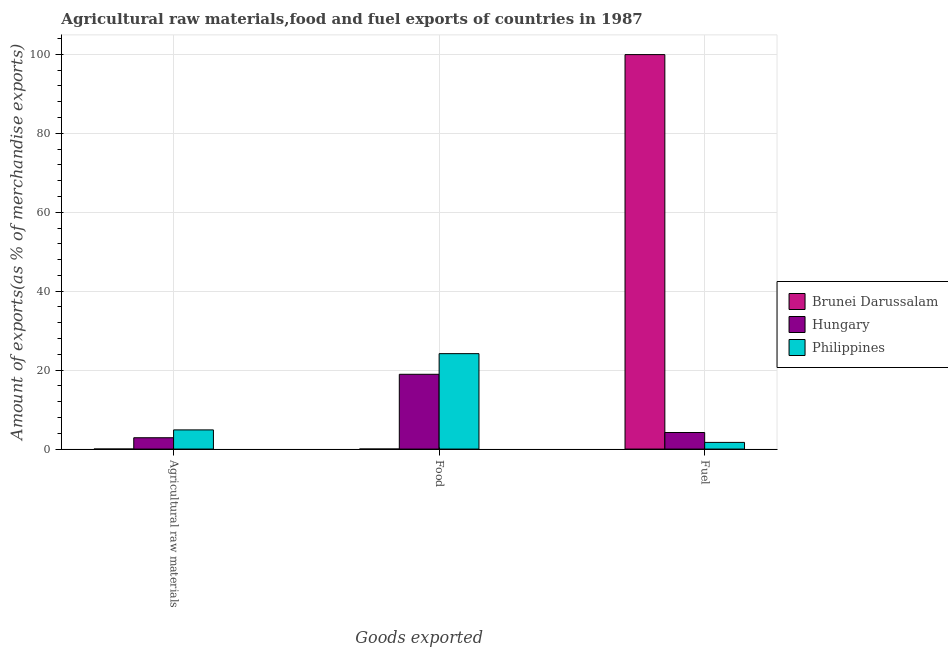How many different coloured bars are there?
Your answer should be compact. 3. How many groups of bars are there?
Provide a short and direct response. 3. Are the number of bars on each tick of the X-axis equal?
Offer a terse response. Yes. How many bars are there on the 1st tick from the left?
Your answer should be very brief. 3. What is the label of the 3rd group of bars from the left?
Your response must be concise. Fuel. What is the percentage of fuel exports in Philippines?
Offer a terse response. 1.69. Across all countries, what is the maximum percentage of raw materials exports?
Ensure brevity in your answer.  4.86. Across all countries, what is the minimum percentage of fuel exports?
Provide a succinct answer. 1.69. In which country was the percentage of food exports minimum?
Offer a terse response. Brunei Darussalam. What is the total percentage of food exports in the graph?
Your answer should be very brief. 43.13. What is the difference between the percentage of food exports in Brunei Darussalam and that in Hungary?
Provide a short and direct response. -18.95. What is the difference between the percentage of fuel exports in Hungary and the percentage of food exports in Brunei Darussalam?
Your answer should be compact. 4.19. What is the average percentage of food exports per country?
Your response must be concise. 14.38. What is the difference between the percentage of fuel exports and percentage of food exports in Hungary?
Ensure brevity in your answer.  -14.75. What is the ratio of the percentage of food exports in Philippines to that in Hungary?
Your response must be concise. 1.28. What is the difference between the highest and the second highest percentage of food exports?
Give a very brief answer. 5.23. What is the difference between the highest and the lowest percentage of raw materials exports?
Offer a very short reply. 4.85. What does the 2nd bar from the left in Agricultural raw materials represents?
Keep it short and to the point. Hungary. What does the 1st bar from the right in Fuel represents?
Provide a succinct answer. Philippines. Is it the case that in every country, the sum of the percentage of raw materials exports and percentage of food exports is greater than the percentage of fuel exports?
Your response must be concise. No. How many bars are there?
Your answer should be compact. 9. What is the difference between two consecutive major ticks on the Y-axis?
Your answer should be compact. 20. Are the values on the major ticks of Y-axis written in scientific E-notation?
Your answer should be compact. No. How are the legend labels stacked?
Your response must be concise. Vertical. What is the title of the graph?
Ensure brevity in your answer.  Agricultural raw materials,food and fuel exports of countries in 1987. Does "Malaysia" appear as one of the legend labels in the graph?
Provide a short and direct response. No. What is the label or title of the X-axis?
Keep it short and to the point. Goods exported. What is the label or title of the Y-axis?
Make the answer very short. Amount of exports(as % of merchandise exports). What is the Amount of exports(as % of merchandise exports) of Brunei Darussalam in Agricultural raw materials?
Ensure brevity in your answer.  0.01. What is the Amount of exports(as % of merchandise exports) of Hungary in Agricultural raw materials?
Make the answer very short. 2.87. What is the Amount of exports(as % of merchandise exports) of Philippines in Agricultural raw materials?
Offer a very short reply. 4.86. What is the Amount of exports(as % of merchandise exports) in Brunei Darussalam in Food?
Your answer should be very brief. 0. What is the Amount of exports(as % of merchandise exports) in Hungary in Food?
Offer a very short reply. 18.95. What is the Amount of exports(as % of merchandise exports) of Philippines in Food?
Offer a terse response. 24.18. What is the Amount of exports(as % of merchandise exports) of Brunei Darussalam in Fuel?
Give a very brief answer. 99.95. What is the Amount of exports(as % of merchandise exports) in Hungary in Fuel?
Ensure brevity in your answer.  4.2. What is the Amount of exports(as % of merchandise exports) in Philippines in Fuel?
Give a very brief answer. 1.69. Across all Goods exported, what is the maximum Amount of exports(as % of merchandise exports) in Brunei Darussalam?
Provide a short and direct response. 99.95. Across all Goods exported, what is the maximum Amount of exports(as % of merchandise exports) in Hungary?
Your answer should be very brief. 18.95. Across all Goods exported, what is the maximum Amount of exports(as % of merchandise exports) in Philippines?
Make the answer very short. 24.18. Across all Goods exported, what is the minimum Amount of exports(as % of merchandise exports) in Brunei Darussalam?
Offer a terse response. 0. Across all Goods exported, what is the minimum Amount of exports(as % of merchandise exports) of Hungary?
Ensure brevity in your answer.  2.87. Across all Goods exported, what is the minimum Amount of exports(as % of merchandise exports) of Philippines?
Offer a very short reply. 1.69. What is the total Amount of exports(as % of merchandise exports) of Brunei Darussalam in the graph?
Offer a terse response. 99.96. What is the total Amount of exports(as % of merchandise exports) in Hungary in the graph?
Ensure brevity in your answer.  26.02. What is the total Amount of exports(as % of merchandise exports) of Philippines in the graph?
Offer a terse response. 30.73. What is the difference between the Amount of exports(as % of merchandise exports) in Brunei Darussalam in Agricultural raw materials and that in Food?
Provide a succinct answer. 0. What is the difference between the Amount of exports(as % of merchandise exports) in Hungary in Agricultural raw materials and that in Food?
Provide a succinct answer. -16.08. What is the difference between the Amount of exports(as % of merchandise exports) of Philippines in Agricultural raw materials and that in Food?
Your answer should be very brief. -19.32. What is the difference between the Amount of exports(as % of merchandise exports) of Brunei Darussalam in Agricultural raw materials and that in Fuel?
Give a very brief answer. -99.95. What is the difference between the Amount of exports(as % of merchandise exports) of Hungary in Agricultural raw materials and that in Fuel?
Make the answer very short. -1.33. What is the difference between the Amount of exports(as % of merchandise exports) in Philippines in Agricultural raw materials and that in Fuel?
Make the answer very short. 3.17. What is the difference between the Amount of exports(as % of merchandise exports) of Brunei Darussalam in Food and that in Fuel?
Offer a very short reply. -99.95. What is the difference between the Amount of exports(as % of merchandise exports) of Hungary in Food and that in Fuel?
Provide a succinct answer. 14.75. What is the difference between the Amount of exports(as % of merchandise exports) in Philippines in Food and that in Fuel?
Offer a terse response. 22.49. What is the difference between the Amount of exports(as % of merchandise exports) of Brunei Darussalam in Agricultural raw materials and the Amount of exports(as % of merchandise exports) of Hungary in Food?
Your answer should be compact. -18.94. What is the difference between the Amount of exports(as % of merchandise exports) of Brunei Darussalam in Agricultural raw materials and the Amount of exports(as % of merchandise exports) of Philippines in Food?
Provide a short and direct response. -24.17. What is the difference between the Amount of exports(as % of merchandise exports) in Hungary in Agricultural raw materials and the Amount of exports(as % of merchandise exports) in Philippines in Food?
Offer a very short reply. -21.31. What is the difference between the Amount of exports(as % of merchandise exports) of Brunei Darussalam in Agricultural raw materials and the Amount of exports(as % of merchandise exports) of Hungary in Fuel?
Your answer should be compact. -4.19. What is the difference between the Amount of exports(as % of merchandise exports) of Brunei Darussalam in Agricultural raw materials and the Amount of exports(as % of merchandise exports) of Philippines in Fuel?
Provide a succinct answer. -1.68. What is the difference between the Amount of exports(as % of merchandise exports) in Hungary in Agricultural raw materials and the Amount of exports(as % of merchandise exports) in Philippines in Fuel?
Keep it short and to the point. 1.18. What is the difference between the Amount of exports(as % of merchandise exports) in Brunei Darussalam in Food and the Amount of exports(as % of merchandise exports) in Hungary in Fuel?
Your response must be concise. -4.19. What is the difference between the Amount of exports(as % of merchandise exports) of Brunei Darussalam in Food and the Amount of exports(as % of merchandise exports) of Philippines in Fuel?
Offer a very short reply. -1.69. What is the difference between the Amount of exports(as % of merchandise exports) of Hungary in Food and the Amount of exports(as % of merchandise exports) of Philippines in Fuel?
Your answer should be very brief. 17.26. What is the average Amount of exports(as % of merchandise exports) of Brunei Darussalam per Goods exported?
Provide a succinct answer. 33.32. What is the average Amount of exports(as % of merchandise exports) in Hungary per Goods exported?
Provide a short and direct response. 8.67. What is the average Amount of exports(as % of merchandise exports) in Philippines per Goods exported?
Keep it short and to the point. 10.24. What is the difference between the Amount of exports(as % of merchandise exports) in Brunei Darussalam and Amount of exports(as % of merchandise exports) in Hungary in Agricultural raw materials?
Offer a very short reply. -2.86. What is the difference between the Amount of exports(as % of merchandise exports) of Brunei Darussalam and Amount of exports(as % of merchandise exports) of Philippines in Agricultural raw materials?
Make the answer very short. -4.85. What is the difference between the Amount of exports(as % of merchandise exports) of Hungary and Amount of exports(as % of merchandise exports) of Philippines in Agricultural raw materials?
Provide a succinct answer. -1.99. What is the difference between the Amount of exports(as % of merchandise exports) in Brunei Darussalam and Amount of exports(as % of merchandise exports) in Hungary in Food?
Your response must be concise. -18.95. What is the difference between the Amount of exports(as % of merchandise exports) of Brunei Darussalam and Amount of exports(as % of merchandise exports) of Philippines in Food?
Offer a very short reply. -24.18. What is the difference between the Amount of exports(as % of merchandise exports) in Hungary and Amount of exports(as % of merchandise exports) in Philippines in Food?
Ensure brevity in your answer.  -5.23. What is the difference between the Amount of exports(as % of merchandise exports) of Brunei Darussalam and Amount of exports(as % of merchandise exports) of Hungary in Fuel?
Your answer should be very brief. 95.76. What is the difference between the Amount of exports(as % of merchandise exports) of Brunei Darussalam and Amount of exports(as % of merchandise exports) of Philippines in Fuel?
Offer a very short reply. 98.26. What is the difference between the Amount of exports(as % of merchandise exports) in Hungary and Amount of exports(as % of merchandise exports) in Philippines in Fuel?
Offer a terse response. 2.51. What is the ratio of the Amount of exports(as % of merchandise exports) of Brunei Darussalam in Agricultural raw materials to that in Food?
Your answer should be compact. 1.88. What is the ratio of the Amount of exports(as % of merchandise exports) of Hungary in Agricultural raw materials to that in Food?
Ensure brevity in your answer.  0.15. What is the ratio of the Amount of exports(as % of merchandise exports) of Philippines in Agricultural raw materials to that in Food?
Provide a succinct answer. 0.2. What is the ratio of the Amount of exports(as % of merchandise exports) of Hungary in Agricultural raw materials to that in Fuel?
Give a very brief answer. 0.68. What is the ratio of the Amount of exports(as % of merchandise exports) of Philippines in Agricultural raw materials to that in Fuel?
Keep it short and to the point. 2.88. What is the ratio of the Amount of exports(as % of merchandise exports) of Hungary in Food to that in Fuel?
Provide a succinct answer. 4.52. What is the ratio of the Amount of exports(as % of merchandise exports) of Philippines in Food to that in Fuel?
Keep it short and to the point. 14.31. What is the difference between the highest and the second highest Amount of exports(as % of merchandise exports) of Brunei Darussalam?
Provide a short and direct response. 99.95. What is the difference between the highest and the second highest Amount of exports(as % of merchandise exports) in Hungary?
Your response must be concise. 14.75. What is the difference between the highest and the second highest Amount of exports(as % of merchandise exports) of Philippines?
Your response must be concise. 19.32. What is the difference between the highest and the lowest Amount of exports(as % of merchandise exports) in Brunei Darussalam?
Your response must be concise. 99.95. What is the difference between the highest and the lowest Amount of exports(as % of merchandise exports) in Hungary?
Offer a very short reply. 16.08. What is the difference between the highest and the lowest Amount of exports(as % of merchandise exports) of Philippines?
Make the answer very short. 22.49. 